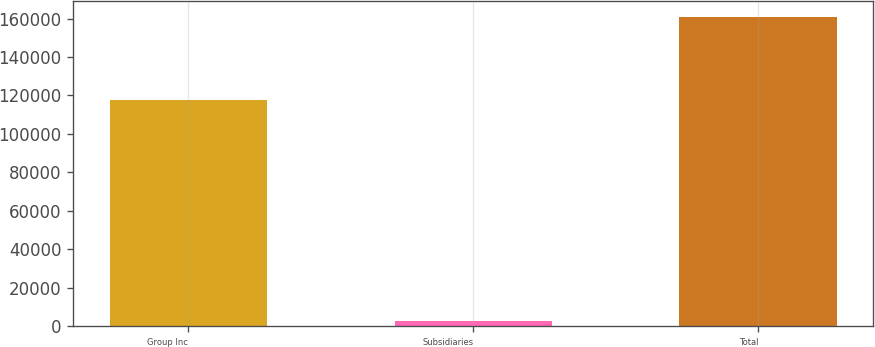Convert chart. <chart><loc_0><loc_0><loc_500><loc_500><bar_chart><fcel>Group Inc<fcel>Subsidiaries<fcel>Total<nl><fcel>117899<fcel>2967<fcel>160965<nl></chart> 